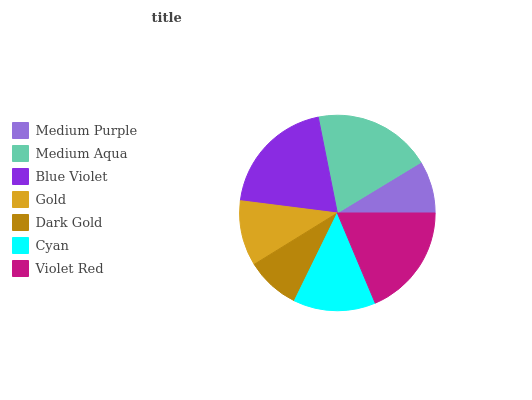Is Medium Purple the minimum?
Answer yes or no. Yes. Is Blue Violet the maximum?
Answer yes or no. Yes. Is Medium Aqua the minimum?
Answer yes or no. No. Is Medium Aqua the maximum?
Answer yes or no. No. Is Medium Aqua greater than Medium Purple?
Answer yes or no. Yes. Is Medium Purple less than Medium Aqua?
Answer yes or no. Yes. Is Medium Purple greater than Medium Aqua?
Answer yes or no. No. Is Medium Aqua less than Medium Purple?
Answer yes or no. No. Is Cyan the high median?
Answer yes or no. Yes. Is Cyan the low median?
Answer yes or no. Yes. Is Medium Purple the high median?
Answer yes or no. No. Is Dark Gold the low median?
Answer yes or no. No. 